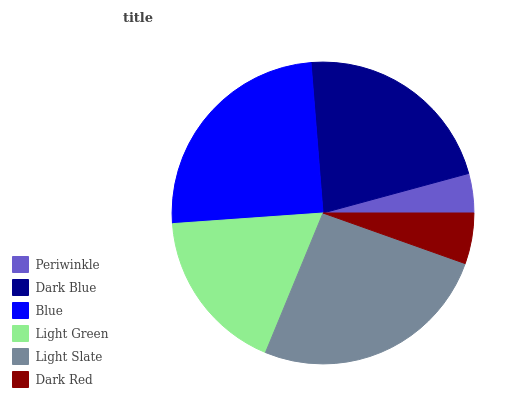Is Periwinkle the minimum?
Answer yes or no. Yes. Is Light Slate the maximum?
Answer yes or no. Yes. Is Dark Blue the minimum?
Answer yes or no. No. Is Dark Blue the maximum?
Answer yes or no. No. Is Dark Blue greater than Periwinkle?
Answer yes or no. Yes. Is Periwinkle less than Dark Blue?
Answer yes or no. Yes. Is Periwinkle greater than Dark Blue?
Answer yes or no. No. Is Dark Blue less than Periwinkle?
Answer yes or no. No. Is Dark Blue the high median?
Answer yes or no. Yes. Is Light Green the low median?
Answer yes or no. Yes. Is Dark Red the high median?
Answer yes or no. No. Is Blue the low median?
Answer yes or no. No. 